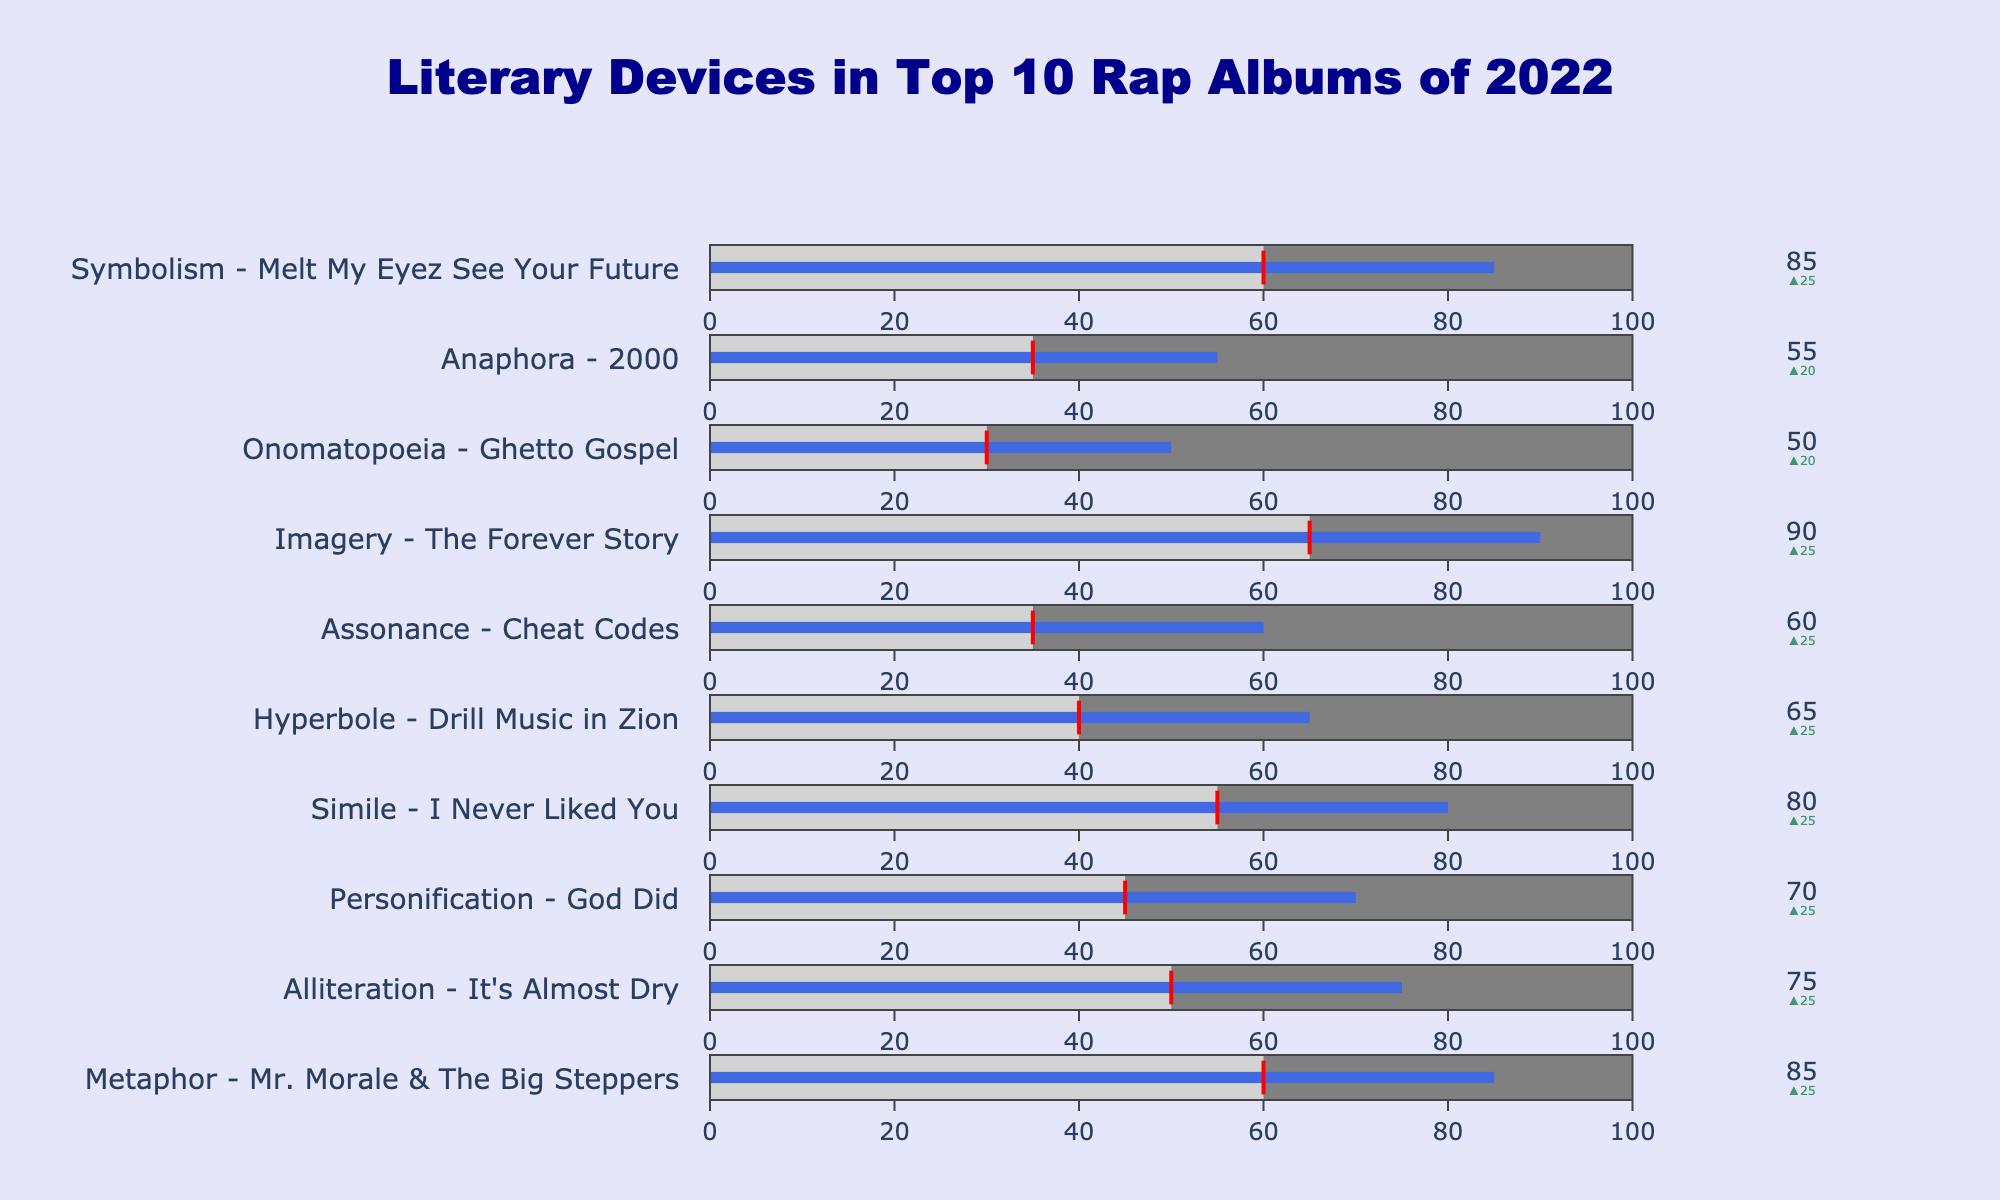What is the title of the chart? The title is displayed at the top center of the chart. It reads "Literary Devices in Top 10 Rap Albums of 2022."
Answer: Literary Devices in Top 10 Rap Albums of 2022 Which album has the highest usage of Imagery, and what is its percentage? Look at the bullet charts and find the one labeled with "Imagery." The corresponding album and its usage percentage are visible within that bullet chart.
Answer: The Forever Story, 90% How does the usage of Personification in "God Did" compare to the industry average? Locate the bullet chart for "Personification" and note both the usage in the album 'God Did' and the industry average. Compare these values.
Answer: 70% in "God Did" vs. 45% industry average What is the comparative range for Hyperbole in the chart? In the bullet chart for "Hyperbole," observe the 'Comparative Range,' which shows the range of the industry average shaded in light gray and the full comparative range marked by the bars.
Answer: 0-100% Which album had a 75% usage of Alliteration, and how does it compare to the industry average? Identify the bullet chart for Alliteration. Note the album name and compare its usage percentage to the industry average shown on the same chart.
Answer: It's Almost Dry, 75% in the album vs. 50% industry average Which literary device shows the smallest difference between usage in the top 10 albums and the industry average? Calculate the differences between usage in the top 10 albums and the industry average for each literary device and identify the smallest difference.
Answer: Onomatopoeia (50% - 30% = 20%) What is the average usage of "Metaphor" and "Simile" in the top 10 albums? Add the usage percentages of "Metaphor" and "Simile," then divide by 2 to find the average.
Answer: (85% + 80%) / 2 = 82.5% Identify the album with the lowest usage of any literary device and specify the device. Scan the bullet charts and identify the literary device that has the lowest usage percentage in the top 10 albums. Note the associated album.
Answer: Ghetto Gospel, Onomatopoeia, 50% Compare the usage of Symbolism in the album "Melt My Eyez See Your Future" to the usage of Assonance in "Cheat Codes." Compare the usage percentages found in the bullet charts for Symbolism and Assonance.
Answer: Symbolism: 85%, Assonance: 60% How many literary devices surpass the 70% usage mark in the top 10 rap albums? List them. Count how many literary devices have bullets that cross the 70% mark in their respective charts. List the names of these literary devices.
Answer: 5 devices: Metaphor, Simile, Imagery, Symbolism, Alliteration 